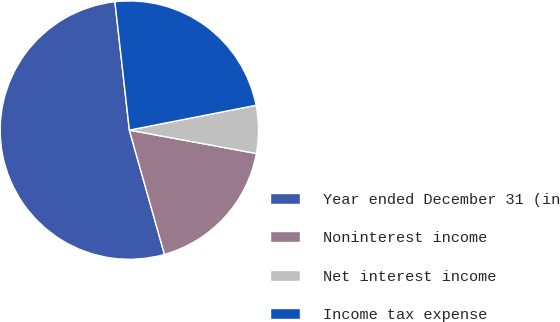<chart> <loc_0><loc_0><loc_500><loc_500><pie_chart><fcel>Year ended December 31 (in<fcel>Noninterest income<fcel>Net interest income<fcel>Income tax expense<nl><fcel>52.6%<fcel>17.72%<fcel>5.98%<fcel>23.7%<nl></chart> 